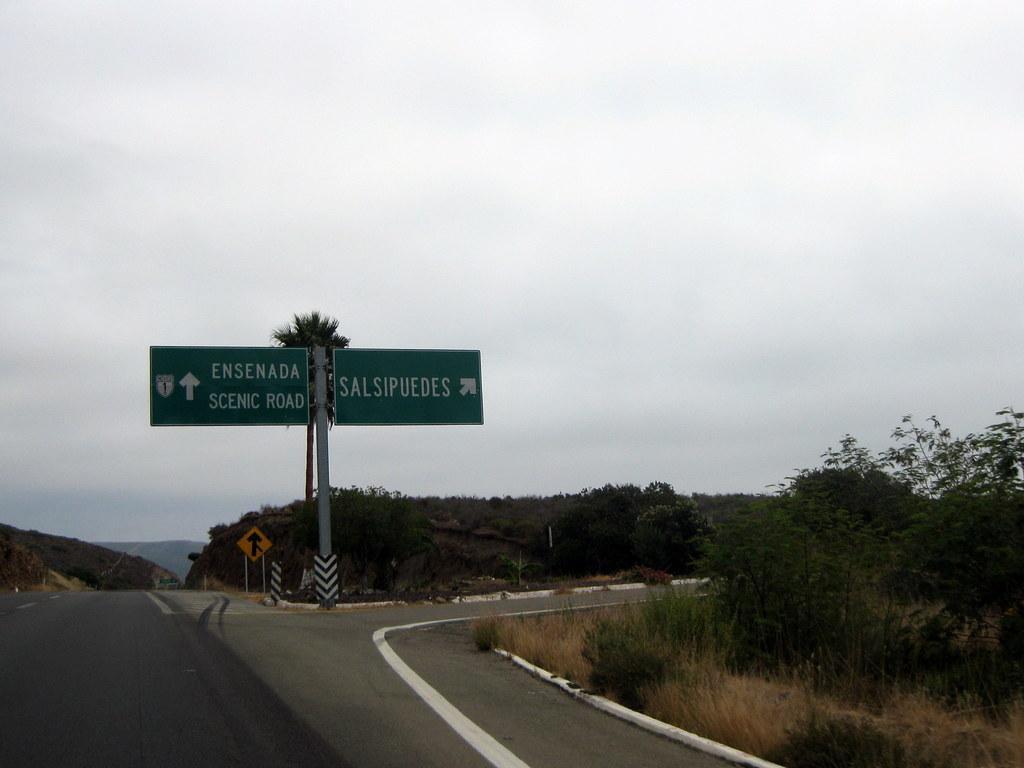How would you summarize this image in a sentence or two? This picture shows few trees and we see roads and couple of name boards to the pole and a design board on the back and a cloudy sky 